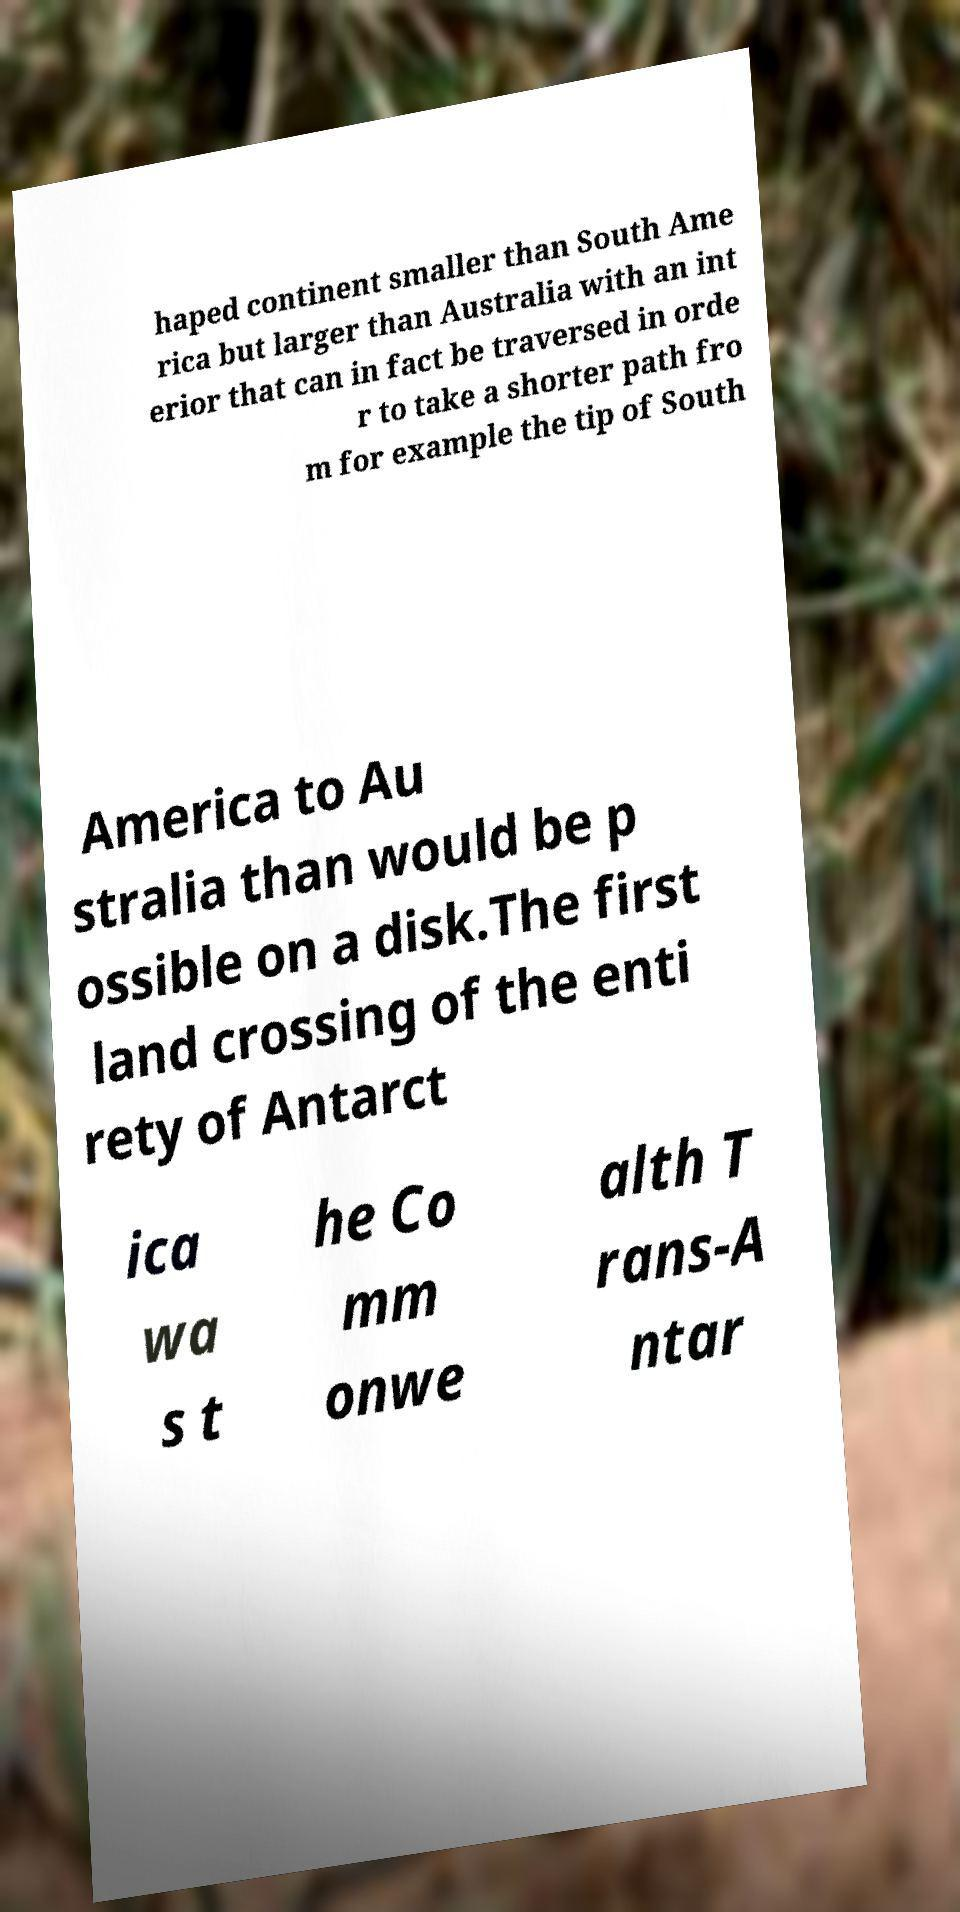I need the written content from this picture converted into text. Can you do that? haped continent smaller than South Ame rica but larger than Australia with an int erior that can in fact be traversed in orde r to take a shorter path fro m for example the tip of South America to Au stralia than would be p ossible on a disk.The first land crossing of the enti rety of Antarct ica wa s t he Co mm onwe alth T rans-A ntar 